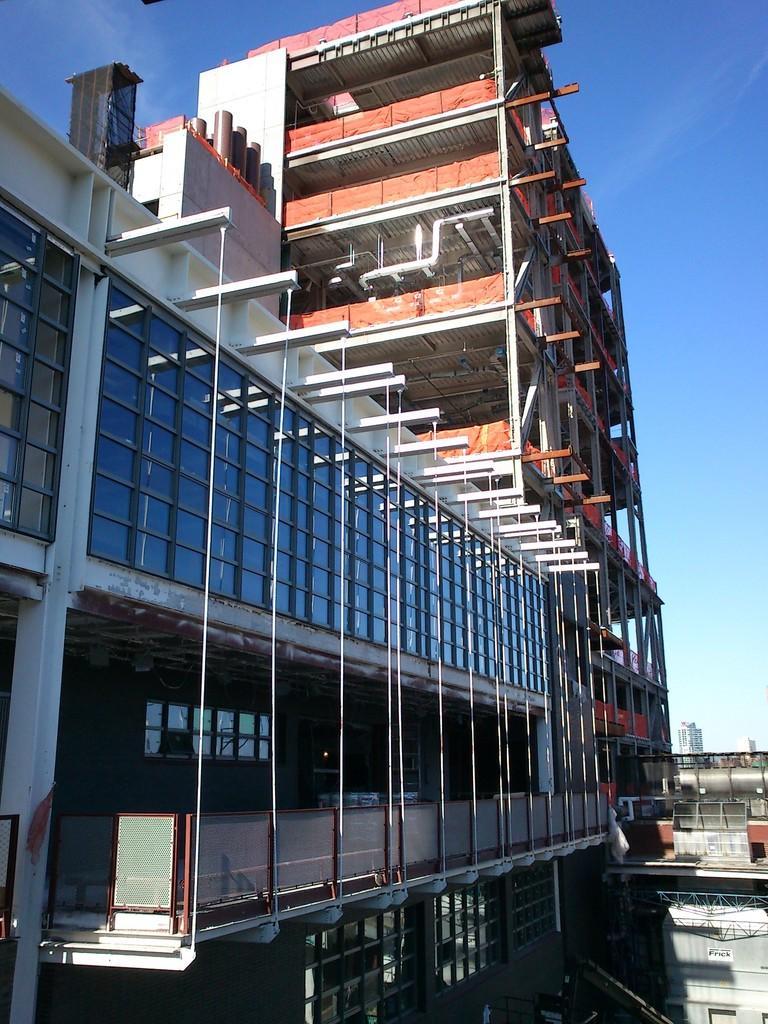In one or two sentences, can you explain what this image depicts? In this image we can see buildings, pipelines and sky. 